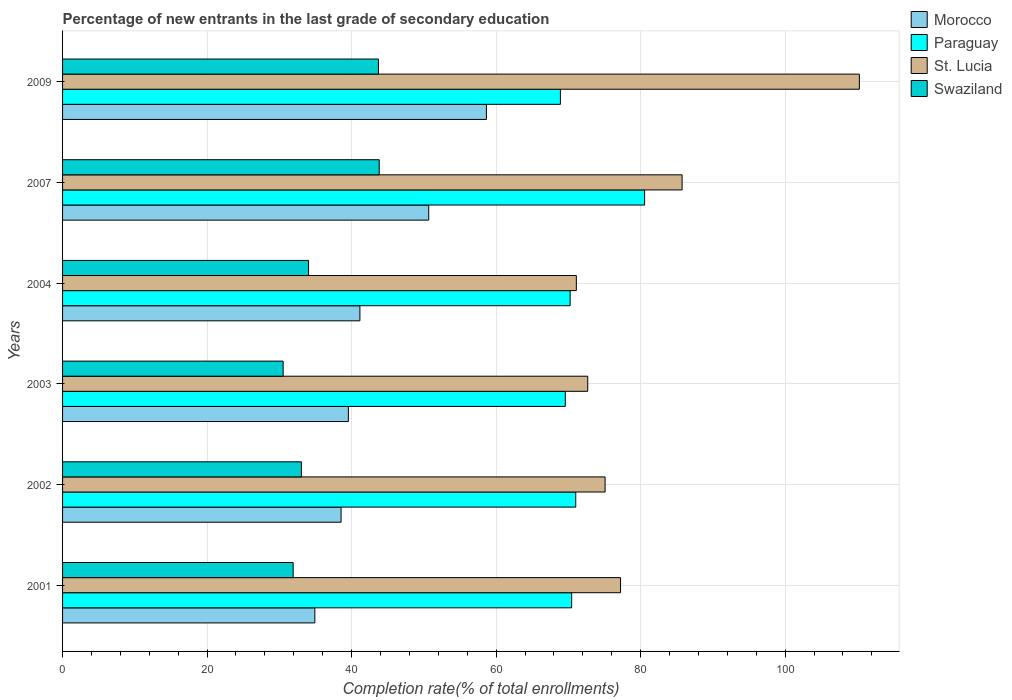How many groups of bars are there?
Offer a terse response. 6. How many bars are there on the 3rd tick from the top?
Ensure brevity in your answer.  4. In how many cases, is the number of bars for a given year not equal to the number of legend labels?
Your answer should be very brief. 0. What is the percentage of new entrants in Morocco in 2001?
Your answer should be very brief. 34.92. Across all years, what is the maximum percentage of new entrants in St. Lucia?
Keep it short and to the point. 110.28. Across all years, what is the minimum percentage of new entrants in Morocco?
Your answer should be very brief. 34.92. In which year was the percentage of new entrants in Swaziland maximum?
Keep it short and to the point. 2007. What is the total percentage of new entrants in Swaziland in the graph?
Keep it short and to the point. 217.09. What is the difference between the percentage of new entrants in Morocco in 2004 and that in 2009?
Provide a succinct answer. -17.51. What is the difference between the percentage of new entrants in Swaziland in 2004 and the percentage of new entrants in St. Lucia in 2003?
Offer a terse response. -38.64. What is the average percentage of new entrants in Morocco per year?
Your response must be concise. 43.92. In the year 2001, what is the difference between the percentage of new entrants in Paraguay and percentage of new entrants in Swaziland?
Give a very brief answer. 38.54. In how many years, is the percentage of new entrants in Paraguay greater than 72 %?
Your answer should be very brief. 1. What is the ratio of the percentage of new entrants in Morocco in 2001 to that in 2003?
Make the answer very short. 0.88. Is the percentage of new entrants in Swaziland in 2002 less than that in 2009?
Offer a terse response. Yes. What is the difference between the highest and the second highest percentage of new entrants in Morocco?
Ensure brevity in your answer.  7.99. What is the difference between the highest and the lowest percentage of new entrants in Paraguay?
Give a very brief answer. 11.65. In how many years, is the percentage of new entrants in St. Lucia greater than the average percentage of new entrants in St. Lucia taken over all years?
Ensure brevity in your answer.  2. What does the 2nd bar from the top in 2001 represents?
Your response must be concise. St. Lucia. What does the 1st bar from the bottom in 2003 represents?
Provide a short and direct response. Morocco. How many bars are there?
Your response must be concise. 24. Are all the bars in the graph horizontal?
Your response must be concise. Yes. Are the values on the major ticks of X-axis written in scientific E-notation?
Your answer should be compact. No. What is the title of the graph?
Keep it short and to the point. Percentage of new entrants in the last grade of secondary education. What is the label or title of the X-axis?
Keep it short and to the point. Completion rate(% of total enrollments). What is the label or title of the Y-axis?
Make the answer very short. Years. What is the Completion rate(% of total enrollments) of Morocco in 2001?
Give a very brief answer. 34.92. What is the Completion rate(% of total enrollments) of Paraguay in 2001?
Offer a terse response. 70.46. What is the Completion rate(% of total enrollments) of St. Lucia in 2001?
Ensure brevity in your answer.  77.23. What is the Completion rate(% of total enrollments) of Swaziland in 2001?
Your answer should be compact. 31.91. What is the Completion rate(% of total enrollments) of Morocco in 2002?
Make the answer very short. 38.55. What is the Completion rate(% of total enrollments) in Paraguay in 2002?
Ensure brevity in your answer.  71.03. What is the Completion rate(% of total enrollments) of St. Lucia in 2002?
Your answer should be very brief. 75.09. What is the Completion rate(% of total enrollments) of Swaziland in 2002?
Your answer should be compact. 33.06. What is the Completion rate(% of total enrollments) in Morocco in 2003?
Offer a terse response. 39.56. What is the Completion rate(% of total enrollments) in Paraguay in 2003?
Give a very brief answer. 69.58. What is the Completion rate(% of total enrollments) of St. Lucia in 2003?
Provide a succinct answer. 72.68. What is the Completion rate(% of total enrollments) in Swaziland in 2003?
Ensure brevity in your answer.  30.53. What is the Completion rate(% of total enrollments) in Morocco in 2004?
Offer a very short reply. 41.15. What is the Completion rate(% of total enrollments) in Paraguay in 2004?
Offer a terse response. 70.25. What is the Completion rate(% of total enrollments) in St. Lucia in 2004?
Your answer should be compact. 71.11. What is the Completion rate(% of total enrollments) in Swaziland in 2004?
Provide a short and direct response. 34.04. What is the Completion rate(% of total enrollments) in Morocco in 2007?
Provide a succinct answer. 50.67. What is the Completion rate(% of total enrollments) of Paraguay in 2007?
Offer a very short reply. 80.55. What is the Completion rate(% of total enrollments) of St. Lucia in 2007?
Your answer should be very brief. 85.74. What is the Completion rate(% of total enrollments) in Swaziland in 2007?
Your answer should be very brief. 43.83. What is the Completion rate(% of total enrollments) in Morocco in 2009?
Offer a very short reply. 58.66. What is the Completion rate(% of total enrollments) of Paraguay in 2009?
Ensure brevity in your answer.  68.9. What is the Completion rate(% of total enrollments) in St. Lucia in 2009?
Keep it short and to the point. 110.28. What is the Completion rate(% of total enrollments) in Swaziland in 2009?
Your response must be concise. 43.72. Across all years, what is the maximum Completion rate(% of total enrollments) in Morocco?
Offer a terse response. 58.66. Across all years, what is the maximum Completion rate(% of total enrollments) in Paraguay?
Your answer should be compact. 80.55. Across all years, what is the maximum Completion rate(% of total enrollments) in St. Lucia?
Make the answer very short. 110.28. Across all years, what is the maximum Completion rate(% of total enrollments) of Swaziland?
Provide a succinct answer. 43.83. Across all years, what is the minimum Completion rate(% of total enrollments) of Morocco?
Offer a very short reply. 34.92. Across all years, what is the minimum Completion rate(% of total enrollments) of Paraguay?
Your response must be concise. 68.9. Across all years, what is the minimum Completion rate(% of total enrollments) of St. Lucia?
Make the answer very short. 71.11. Across all years, what is the minimum Completion rate(% of total enrollments) in Swaziland?
Offer a very short reply. 30.53. What is the total Completion rate(% of total enrollments) of Morocco in the graph?
Your response must be concise. 263.51. What is the total Completion rate(% of total enrollments) in Paraguay in the graph?
Make the answer very short. 430.76. What is the total Completion rate(% of total enrollments) in St. Lucia in the graph?
Keep it short and to the point. 492.12. What is the total Completion rate(% of total enrollments) in Swaziland in the graph?
Your response must be concise. 217.09. What is the difference between the Completion rate(% of total enrollments) of Morocco in 2001 and that in 2002?
Keep it short and to the point. -3.63. What is the difference between the Completion rate(% of total enrollments) of Paraguay in 2001 and that in 2002?
Provide a succinct answer. -0.57. What is the difference between the Completion rate(% of total enrollments) in St. Lucia in 2001 and that in 2002?
Provide a succinct answer. 2.14. What is the difference between the Completion rate(% of total enrollments) in Swaziland in 2001 and that in 2002?
Your answer should be very brief. -1.14. What is the difference between the Completion rate(% of total enrollments) in Morocco in 2001 and that in 2003?
Offer a very short reply. -4.64. What is the difference between the Completion rate(% of total enrollments) of Paraguay in 2001 and that in 2003?
Provide a succinct answer. 0.88. What is the difference between the Completion rate(% of total enrollments) in St. Lucia in 2001 and that in 2003?
Ensure brevity in your answer.  4.54. What is the difference between the Completion rate(% of total enrollments) in Swaziland in 2001 and that in 2003?
Provide a short and direct response. 1.39. What is the difference between the Completion rate(% of total enrollments) of Morocco in 2001 and that in 2004?
Provide a short and direct response. -6.23. What is the difference between the Completion rate(% of total enrollments) of Paraguay in 2001 and that in 2004?
Offer a very short reply. 0.21. What is the difference between the Completion rate(% of total enrollments) of St. Lucia in 2001 and that in 2004?
Provide a short and direct response. 6.12. What is the difference between the Completion rate(% of total enrollments) of Swaziland in 2001 and that in 2004?
Give a very brief answer. -2.13. What is the difference between the Completion rate(% of total enrollments) in Morocco in 2001 and that in 2007?
Keep it short and to the point. -15.76. What is the difference between the Completion rate(% of total enrollments) of Paraguay in 2001 and that in 2007?
Ensure brevity in your answer.  -10.1. What is the difference between the Completion rate(% of total enrollments) of St. Lucia in 2001 and that in 2007?
Give a very brief answer. -8.52. What is the difference between the Completion rate(% of total enrollments) of Swaziland in 2001 and that in 2007?
Your response must be concise. -11.91. What is the difference between the Completion rate(% of total enrollments) of Morocco in 2001 and that in 2009?
Your response must be concise. -23.74. What is the difference between the Completion rate(% of total enrollments) of Paraguay in 2001 and that in 2009?
Ensure brevity in your answer.  1.56. What is the difference between the Completion rate(% of total enrollments) in St. Lucia in 2001 and that in 2009?
Offer a terse response. -33.05. What is the difference between the Completion rate(% of total enrollments) in Swaziland in 2001 and that in 2009?
Give a very brief answer. -11.8. What is the difference between the Completion rate(% of total enrollments) of Morocco in 2002 and that in 2003?
Make the answer very short. -1.01. What is the difference between the Completion rate(% of total enrollments) in Paraguay in 2002 and that in 2003?
Give a very brief answer. 1.45. What is the difference between the Completion rate(% of total enrollments) in St. Lucia in 2002 and that in 2003?
Keep it short and to the point. 2.4. What is the difference between the Completion rate(% of total enrollments) of Swaziland in 2002 and that in 2003?
Offer a very short reply. 2.53. What is the difference between the Completion rate(% of total enrollments) in Morocco in 2002 and that in 2004?
Keep it short and to the point. -2.61. What is the difference between the Completion rate(% of total enrollments) of Paraguay in 2002 and that in 2004?
Keep it short and to the point. 0.78. What is the difference between the Completion rate(% of total enrollments) of St. Lucia in 2002 and that in 2004?
Offer a very short reply. 3.98. What is the difference between the Completion rate(% of total enrollments) of Swaziland in 2002 and that in 2004?
Offer a very short reply. -0.99. What is the difference between the Completion rate(% of total enrollments) of Morocco in 2002 and that in 2007?
Make the answer very short. -12.13. What is the difference between the Completion rate(% of total enrollments) in Paraguay in 2002 and that in 2007?
Provide a succinct answer. -9.53. What is the difference between the Completion rate(% of total enrollments) in St. Lucia in 2002 and that in 2007?
Provide a short and direct response. -10.66. What is the difference between the Completion rate(% of total enrollments) of Swaziland in 2002 and that in 2007?
Keep it short and to the point. -10.77. What is the difference between the Completion rate(% of total enrollments) of Morocco in 2002 and that in 2009?
Provide a succinct answer. -20.12. What is the difference between the Completion rate(% of total enrollments) of Paraguay in 2002 and that in 2009?
Your answer should be very brief. 2.13. What is the difference between the Completion rate(% of total enrollments) in St. Lucia in 2002 and that in 2009?
Provide a succinct answer. -35.19. What is the difference between the Completion rate(% of total enrollments) in Swaziland in 2002 and that in 2009?
Provide a succinct answer. -10.66. What is the difference between the Completion rate(% of total enrollments) in Morocco in 2003 and that in 2004?
Offer a terse response. -1.6. What is the difference between the Completion rate(% of total enrollments) in Paraguay in 2003 and that in 2004?
Your answer should be compact. -0.67. What is the difference between the Completion rate(% of total enrollments) of St. Lucia in 2003 and that in 2004?
Make the answer very short. 1.58. What is the difference between the Completion rate(% of total enrollments) of Swaziland in 2003 and that in 2004?
Keep it short and to the point. -3.52. What is the difference between the Completion rate(% of total enrollments) in Morocco in 2003 and that in 2007?
Keep it short and to the point. -11.12. What is the difference between the Completion rate(% of total enrollments) of Paraguay in 2003 and that in 2007?
Your answer should be very brief. -10.97. What is the difference between the Completion rate(% of total enrollments) of St. Lucia in 2003 and that in 2007?
Give a very brief answer. -13.06. What is the difference between the Completion rate(% of total enrollments) of Swaziland in 2003 and that in 2007?
Provide a short and direct response. -13.3. What is the difference between the Completion rate(% of total enrollments) of Morocco in 2003 and that in 2009?
Offer a very short reply. -19.11. What is the difference between the Completion rate(% of total enrollments) of Paraguay in 2003 and that in 2009?
Offer a terse response. 0.68. What is the difference between the Completion rate(% of total enrollments) in St. Lucia in 2003 and that in 2009?
Offer a terse response. -37.59. What is the difference between the Completion rate(% of total enrollments) in Swaziland in 2003 and that in 2009?
Ensure brevity in your answer.  -13.19. What is the difference between the Completion rate(% of total enrollments) of Morocco in 2004 and that in 2007?
Provide a succinct answer. -9.52. What is the difference between the Completion rate(% of total enrollments) of Paraguay in 2004 and that in 2007?
Make the answer very short. -10.3. What is the difference between the Completion rate(% of total enrollments) of St. Lucia in 2004 and that in 2007?
Make the answer very short. -14.64. What is the difference between the Completion rate(% of total enrollments) in Swaziland in 2004 and that in 2007?
Your response must be concise. -9.78. What is the difference between the Completion rate(% of total enrollments) in Morocco in 2004 and that in 2009?
Your answer should be compact. -17.51. What is the difference between the Completion rate(% of total enrollments) in Paraguay in 2004 and that in 2009?
Provide a short and direct response. 1.35. What is the difference between the Completion rate(% of total enrollments) of St. Lucia in 2004 and that in 2009?
Give a very brief answer. -39.17. What is the difference between the Completion rate(% of total enrollments) of Swaziland in 2004 and that in 2009?
Ensure brevity in your answer.  -9.67. What is the difference between the Completion rate(% of total enrollments) in Morocco in 2007 and that in 2009?
Make the answer very short. -7.99. What is the difference between the Completion rate(% of total enrollments) in Paraguay in 2007 and that in 2009?
Offer a terse response. 11.65. What is the difference between the Completion rate(% of total enrollments) in St. Lucia in 2007 and that in 2009?
Your response must be concise. -24.53. What is the difference between the Completion rate(% of total enrollments) of Swaziland in 2007 and that in 2009?
Ensure brevity in your answer.  0.11. What is the difference between the Completion rate(% of total enrollments) in Morocco in 2001 and the Completion rate(% of total enrollments) in Paraguay in 2002?
Make the answer very short. -36.11. What is the difference between the Completion rate(% of total enrollments) of Morocco in 2001 and the Completion rate(% of total enrollments) of St. Lucia in 2002?
Keep it short and to the point. -40.17. What is the difference between the Completion rate(% of total enrollments) in Morocco in 2001 and the Completion rate(% of total enrollments) in Swaziland in 2002?
Give a very brief answer. 1.86. What is the difference between the Completion rate(% of total enrollments) of Paraguay in 2001 and the Completion rate(% of total enrollments) of St. Lucia in 2002?
Make the answer very short. -4.63. What is the difference between the Completion rate(% of total enrollments) in Paraguay in 2001 and the Completion rate(% of total enrollments) in Swaziland in 2002?
Your response must be concise. 37.4. What is the difference between the Completion rate(% of total enrollments) in St. Lucia in 2001 and the Completion rate(% of total enrollments) in Swaziland in 2002?
Keep it short and to the point. 44.17. What is the difference between the Completion rate(% of total enrollments) of Morocco in 2001 and the Completion rate(% of total enrollments) of Paraguay in 2003?
Make the answer very short. -34.66. What is the difference between the Completion rate(% of total enrollments) of Morocco in 2001 and the Completion rate(% of total enrollments) of St. Lucia in 2003?
Offer a terse response. -37.76. What is the difference between the Completion rate(% of total enrollments) in Morocco in 2001 and the Completion rate(% of total enrollments) in Swaziland in 2003?
Your response must be concise. 4.39. What is the difference between the Completion rate(% of total enrollments) in Paraguay in 2001 and the Completion rate(% of total enrollments) in St. Lucia in 2003?
Provide a short and direct response. -2.23. What is the difference between the Completion rate(% of total enrollments) of Paraguay in 2001 and the Completion rate(% of total enrollments) of Swaziland in 2003?
Keep it short and to the point. 39.93. What is the difference between the Completion rate(% of total enrollments) in St. Lucia in 2001 and the Completion rate(% of total enrollments) in Swaziland in 2003?
Offer a terse response. 46.7. What is the difference between the Completion rate(% of total enrollments) of Morocco in 2001 and the Completion rate(% of total enrollments) of Paraguay in 2004?
Provide a short and direct response. -35.33. What is the difference between the Completion rate(% of total enrollments) of Morocco in 2001 and the Completion rate(% of total enrollments) of St. Lucia in 2004?
Offer a very short reply. -36.19. What is the difference between the Completion rate(% of total enrollments) in Morocco in 2001 and the Completion rate(% of total enrollments) in Swaziland in 2004?
Your answer should be very brief. 0.88. What is the difference between the Completion rate(% of total enrollments) in Paraguay in 2001 and the Completion rate(% of total enrollments) in St. Lucia in 2004?
Your answer should be very brief. -0.65. What is the difference between the Completion rate(% of total enrollments) of Paraguay in 2001 and the Completion rate(% of total enrollments) of Swaziland in 2004?
Provide a short and direct response. 36.41. What is the difference between the Completion rate(% of total enrollments) of St. Lucia in 2001 and the Completion rate(% of total enrollments) of Swaziland in 2004?
Offer a very short reply. 43.18. What is the difference between the Completion rate(% of total enrollments) in Morocco in 2001 and the Completion rate(% of total enrollments) in Paraguay in 2007?
Keep it short and to the point. -45.63. What is the difference between the Completion rate(% of total enrollments) in Morocco in 2001 and the Completion rate(% of total enrollments) in St. Lucia in 2007?
Provide a succinct answer. -50.82. What is the difference between the Completion rate(% of total enrollments) of Morocco in 2001 and the Completion rate(% of total enrollments) of Swaziland in 2007?
Your answer should be very brief. -8.91. What is the difference between the Completion rate(% of total enrollments) of Paraguay in 2001 and the Completion rate(% of total enrollments) of St. Lucia in 2007?
Provide a succinct answer. -15.29. What is the difference between the Completion rate(% of total enrollments) in Paraguay in 2001 and the Completion rate(% of total enrollments) in Swaziland in 2007?
Offer a terse response. 26.63. What is the difference between the Completion rate(% of total enrollments) of St. Lucia in 2001 and the Completion rate(% of total enrollments) of Swaziland in 2007?
Ensure brevity in your answer.  33.4. What is the difference between the Completion rate(% of total enrollments) in Morocco in 2001 and the Completion rate(% of total enrollments) in Paraguay in 2009?
Your response must be concise. -33.98. What is the difference between the Completion rate(% of total enrollments) of Morocco in 2001 and the Completion rate(% of total enrollments) of St. Lucia in 2009?
Your answer should be compact. -75.36. What is the difference between the Completion rate(% of total enrollments) of Morocco in 2001 and the Completion rate(% of total enrollments) of Swaziland in 2009?
Give a very brief answer. -8.8. What is the difference between the Completion rate(% of total enrollments) in Paraguay in 2001 and the Completion rate(% of total enrollments) in St. Lucia in 2009?
Give a very brief answer. -39.82. What is the difference between the Completion rate(% of total enrollments) in Paraguay in 2001 and the Completion rate(% of total enrollments) in Swaziland in 2009?
Provide a succinct answer. 26.74. What is the difference between the Completion rate(% of total enrollments) of St. Lucia in 2001 and the Completion rate(% of total enrollments) of Swaziland in 2009?
Your answer should be very brief. 33.51. What is the difference between the Completion rate(% of total enrollments) of Morocco in 2002 and the Completion rate(% of total enrollments) of Paraguay in 2003?
Your answer should be very brief. -31.03. What is the difference between the Completion rate(% of total enrollments) of Morocco in 2002 and the Completion rate(% of total enrollments) of St. Lucia in 2003?
Make the answer very short. -34.14. What is the difference between the Completion rate(% of total enrollments) in Morocco in 2002 and the Completion rate(% of total enrollments) in Swaziland in 2003?
Offer a very short reply. 8.02. What is the difference between the Completion rate(% of total enrollments) in Paraguay in 2002 and the Completion rate(% of total enrollments) in St. Lucia in 2003?
Your response must be concise. -1.66. What is the difference between the Completion rate(% of total enrollments) of Paraguay in 2002 and the Completion rate(% of total enrollments) of Swaziland in 2003?
Your answer should be compact. 40.5. What is the difference between the Completion rate(% of total enrollments) in St. Lucia in 2002 and the Completion rate(% of total enrollments) in Swaziland in 2003?
Offer a terse response. 44.56. What is the difference between the Completion rate(% of total enrollments) of Morocco in 2002 and the Completion rate(% of total enrollments) of Paraguay in 2004?
Offer a terse response. -31.7. What is the difference between the Completion rate(% of total enrollments) in Morocco in 2002 and the Completion rate(% of total enrollments) in St. Lucia in 2004?
Offer a terse response. -32.56. What is the difference between the Completion rate(% of total enrollments) of Morocco in 2002 and the Completion rate(% of total enrollments) of Swaziland in 2004?
Ensure brevity in your answer.  4.5. What is the difference between the Completion rate(% of total enrollments) in Paraguay in 2002 and the Completion rate(% of total enrollments) in St. Lucia in 2004?
Provide a succinct answer. -0.08. What is the difference between the Completion rate(% of total enrollments) of Paraguay in 2002 and the Completion rate(% of total enrollments) of Swaziland in 2004?
Keep it short and to the point. 36.98. What is the difference between the Completion rate(% of total enrollments) of St. Lucia in 2002 and the Completion rate(% of total enrollments) of Swaziland in 2004?
Your answer should be very brief. 41.04. What is the difference between the Completion rate(% of total enrollments) of Morocco in 2002 and the Completion rate(% of total enrollments) of Paraguay in 2007?
Offer a very short reply. -42.01. What is the difference between the Completion rate(% of total enrollments) in Morocco in 2002 and the Completion rate(% of total enrollments) in St. Lucia in 2007?
Provide a succinct answer. -47.2. What is the difference between the Completion rate(% of total enrollments) of Morocco in 2002 and the Completion rate(% of total enrollments) of Swaziland in 2007?
Your answer should be compact. -5.28. What is the difference between the Completion rate(% of total enrollments) in Paraguay in 2002 and the Completion rate(% of total enrollments) in St. Lucia in 2007?
Keep it short and to the point. -14.72. What is the difference between the Completion rate(% of total enrollments) in Paraguay in 2002 and the Completion rate(% of total enrollments) in Swaziland in 2007?
Make the answer very short. 27.2. What is the difference between the Completion rate(% of total enrollments) of St. Lucia in 2002 and the Completion rate(% of total enrollments) of Swaziland in 2007?
Offer a very short reply. 31.26. What is the difference between the Completion rate(% of total enrollments) of Morocco in 2002 and the Completion rate(% of total enrollments) of Paraguay in 2009?
Keep it short and to the point. -30.35. What is the difference between the Completion rate(% of total enrollments) of Morocco in 2002 and the Completion rate(% of total enrollments) of St. Lucia in 2009?
Your answer should be compact. -71.73. What is the difference between the Completion rate(% of total enrollments) of Morocco in 2002 and the Completion rate(% of total enrollments) of Swaziland in 2009?
Your response must be concise. -5.17. What is the difference between the Completion rate(% of total enrollments) in Paraguay in 2002 and the Completion rate(% of total enrollments) in St. Lucia in 2009?
Your answer should be compact. -39.25. What is the difference between the Completion rate(% of total enrollments) of Paraguay in 2002 and the Completion rate(% of total enrollments) of Swaziland in 2009?
Give a very brief answer. 27.31. What is the difference between the Completion rate(% of total enrollments) in St. Lucia in 2002 and the Completion rate(% of total enrollments) in Swaziland in 2009?
Your answer should be compact. 31.37. What is the difference between the Completion rate(% of total enrollments) in Morocco in 2003 and the Completion rate(% of total enrollments) in Paraguay in 2004?
Make the answer very short. -30.69. What is the difference between the Completion rate(% of total enrollments) in Morocco in 2003 and the Completion rate(% of total enrollments) in St. Lucia in 2004?
Offer a terse response. -31.55. What is the difference between the Completion rate(% of total enrollments) of Morocco in 2003 and the Completion rate(% of total enrollments) of Swaziland in 2004?
Ensure brevity in your answer.  5.51. What is the difference between the Completion rate(% of total enrollments) of Paraguay in 2003 and the Completion rate(% of total enrollments) of St. Lucia in 2004?
Give a very brief answer. -1.53. What is the difference between the Completion rate(% of total enrollments) in Paraguay in 2003 and the Completion rate(% of total enrollments) in Swaziland in 2004?
Provide a short and direct response. 35.54. What is the difference between the Completion rate(% of total enrollments) in St. Lucia in 2003 and the Completion rate(% of total enrollments) in Swaziland in 2004?
Your answer should be very brief. 38.64. What is the difference between the Completion rate(% of total enrollments) in Morocco in 2003 and the Completion rate(% of total enrollments) in Paraguay in 2007?
Give a very brief answer. -41. What is the difference between the Completion rate(% of total enrollments) in Morocco in 2003 and the Completion rate(% of total enrollments) in St. Lucia in 2007?
Your response must be concise. -46.19. What is the difference between the Completion rate(% of total enrollments) in Morocco in 2003 and the Completion rate(% of total enrollments) in Swaziland in 2007?
Provide a succinct answer. -4.27. What is the difference between the Completion rate(% of total enrollments) of Paraguay in 2003 and the Completion rate(% of total enrollments) of St. Lucia in 2007?
Make the answer very short. -16.16. What is the difference between the Completion rate(% of total enrollments) in Paraguay in 2003 and the Completion rate(% of total enrollments) in Swaziland in 2007?
Offer a terse response. 25.75. What is the difference between the Completion rate(% of total enrollments) in St. Lucia in 2003 and the Completion rate(% of total enrollments) in Swaziland in 2007?
Offer a very short reply. 28.86. What is the difference between the Completion rate(% of total enrollments) in Morocco in 2003 and the Completion rate(% of total enrollments) in Paraguay in 2009?
Ensure brevity in your answer.  -29.34. What is the difference between the Completion rate(% of total enrollments) in Morocco in 2003 and the Completion rate(% of total enrollments) in St. Lucia in 2009?
Offer a terse response. -70.72. What is the difference between the Completion rate(% of total enrollments) in Morocco in 2003 and the Completion rate(% of total enrollments) in Swaziland in 2009?
Provide a short and direct response. -4.16. What is the difference between the Completion rate(% of total enrollments) in Paraguay in 2003 and the Completion rate(% of total enrollments) in St. Lucia in 2009?
Offer a very short reply. -40.7. What is the difference between the Completion rate(% of total enrollments) in Paraguay in 2003 and the Completion rate(% of total enrollments) in Swaziland in 2009?
Your answer should be compact. 25.86. What is the difference between the Completion rate(% of total enrollments) of St. Lucia in 2003 and the Completion rate(% of total enrollments) of Swaziland in 2009?
Provide a succinct answer. 28.97. What is the difference between the Completion rate(% of total enrollments) of Morocco in 2004 and the Completion rate(% of total enrollments) of Paraguay in 2007?
Provide a succinct answer. -39.4. What is the difference between the Completion rate(% of total enrollments) of Morocco in 2004 and the Completion rate(% of total enrollments) of St. Lucia in 2007?
Your answer should be very brief. -44.59. What is the difference between the Completion rate(% of total enrollments) in Morocco in 2004 and the Completion rate(% of total enrollments) in Swaziland in 2007?
Offer a terse response. -2.68. What is the difference between the Completion rate(% of total enrollments) of Paraguay in 2004 and the Completion rate(% of total enrollments) of St. Lucia in 2007?
Offer a very short reply. -15.5. What is the difference between the Completion rate(% of total enrollments) of Paraguay in 2004 and the Completion rate(% of total enrollments) of Swaziland in 2007?
Offer a terse response. 26.42. What is the difference between the Completion rate(% of total enrollments) in St. Lucia in 2004 and the Completion rate(% of total enrollments) in Swaziland in 2007?
Ensure brevity in your answer.  27.28. What is the difference between the Completion rate(% of total enrollments) in Morocco in 2004 and the Completion rate(% of total enrollments) in Paraguay in 2009?
Offer a very short reply. -27.75. What is the difference between the Completion rate(% of total enrollments) of Morocco in 2004 and the Completion rate(% of total enrollments) of St. Lucia in 2009?
Your answer should be compact. -69.12. What is the difference between the Completion rate(% of total enrollments) in Morocco in 2004 and the Completion rate(% of total enrollments) in Swaziland in 2009?
Ensure brevity in your answer.  -2.57. What is the difference between the Completion rate(% of total enrollments) in Paraguay in 2004 and the Completion rate(% of total enrollments) in St. Lucia in 2009?
Your answer should be very brief. -40.03. What is the difference between the Completion rate(% of total enrollments) in Paraguay in 2004 and the Completion rate(% of total enrollments) in Swaziland in 2009?
Your response must be concise. 26.53. What is the difference between the Completion rate(% of total enrollments) in St. Lucia in 2004 and the Completion rate(% of total enrollments) in Swaziland in 2009?
Your answer should be very brief. 27.39. What is the difference between the Completion rate(% of total enrollments) of Morocco in 2007 and the Completion rate(% of total enrollments) of Paraguay in 2009?
Provide a succinct answer. -18.23. What is the difference between the Completion rate(% of total enrollments) in Morocco in 2007 and the Completion rate(% of total enrollments) in St. Lucia in 2009?
Offer a terse response. -59.6. What is the difference between the Completion rate(% of total enrollments) of Morocco in 2007 and the Completion rate(% of total enrollments) of Swaziland in 2009?
Offer a very short reply. 6.96. What is the difference between the Completion rate(% of total enrollments) of Paraguay in 2007 and the Completion rate(% of total enrollments) of St. Lucia in 2009?
Make the answer very short. -29.72. What is the difference between the Completion rate(% of total enrollments) in Paraguay in 2007 and the Completion rate(% of total enrollments) in Swaziland in 2009?
Make the answer very short. 36.83. What is the difference between the Completion rate(% of total enrollments) of St. Lucia in 2007 and the Completion rate(% of total enrollments) of Swaziland in 2009?
Make the answer very short. 42.03. What is the average Completion rate(% of total enrollments) in Morocco per year?
Your answer should be compact. 43.92. What is the average Completion rate(% of total enrollments) of Paraguay per year?
Provide a succinct answer. 71.79. What is the average Completion rate(% of total enrollments) in St. Lucia per year?
Keep it short and to the point. 82.02. What is the average Completion rate(% of total enrollments) of Swaziland per year?
Offer a very short reply. 36.18. In the year 2001, what is the difference between the Completion rate(% of total enrollments) of Morocco and Completion rate(% of total enrollments) of Paraguay?
Give a very brief answer. -35.54. In the year 2001, what is the difference between the Completion rate(% of total enrollments) in Morocco and Completion rate(% of total enrollments) in St. Lucia?
Provide a succinct answer. -42.31. In the year 2001, what is the difference between the Completion rate(% of total enrollments) of Morocco and Completion rate(% of total enrollments) of Swaziland?
Offer a terse response. 3. In the year 2001, what is the difference between the Completion rate(% of total enrollments) of Paraguay and Completion rate(% of total enrollments) of St. Lucia?
Your answer should be compact. -6.77. In the year 2001, what is the difference between the Completion rate(% of total enrollments) of Paraguay and Completion rate(% of total enrollments) of Swaziland?
Keep it short and to the point. 38.54. In the year 2001, what is the difference between the Completion rate(% of total enrollments) of St. Lucia and Completion rate(% of total enrollments) of Swaziland?
Ensure brevity in your answer.  45.31. In the year 2002, what is the difference between the Completion rate(% of total enrollments) of Morocco and Completion rate(% of total enrollments) of Paraguay?
Your answer should be very brief. -32.48. In the year 2002, what is the difference between the Completion rate(% of total enrollments) in Morocco and Completion rate(% of total enrollments) in St. Lucia?
Make the answer very short. -36.54. In the year 2002, what is the difference between the Completion rate(% of total enrollments) in Morocco and Completion rate(% of total enrollments) in Swaziland?
Provide a short and direct response. 5.49. In the year 2002, what is the difference between the Completion rate(% of total enrollments) in Paraguay and Completion rate(% of total enrollments) in St. Lucia?
Make the answer very short. -4.06. In the year 2002, what is the difference between the Completion rate(% of total enrollments) in Paraguay and Completion rate(% of total enrollments) in Swaziland?
Your response must be concise. 37.97. In the year 2002, what is the difference between the Completion rate(% of total enrollments) of St. Lucia and Completion rate(% of total enrollments) of Swaziland?
Your answer should be compact. 42.03. In the year 2003, what is the difference between the Completion rate(% of total enrollments) of Morocco and Completion rate(% of total enrollments) of Paraguay?
Provide a succinct answer. -30.02. In the year 2003, what is the difference between the Completion rate(% of total enrollments) in Morocco and Completion rate(% of total enrollments) in St. Lucia?
Your answer should be very brief. -33.13. In the year 2003, what is the difference between the Completion rate(% of total enrollments) of Morocco and Completion rate(% of total enrollments) of Swaziland?
Ensure brevity in your answer.  9.03. In the year 2003, what is the difference between the Completion rate(% of total enrollments) in Paraguay and Completion rate(% of total enrollments) in St. Lucia?
Keep it short and to the point. -3.1. In the year 2003, what is the difference between the Completion rate(% of total enrollments) in Paraguay and Completion rate(% of total enrollments) in Swaziland?
Keep it short and to the point. 39.05. In the year 2003, what is the difference between the Completion rate(% of total enrollments) in St. Lucia and Completion rate(% of total enrollments) in Swaziland?
Your answer should be compact. 42.16. In the year 2004, what is the difference between the Completion rate(% of total enrollments) of Morocco and Completion rate(% of total enrollments) of Paraguay?
Provide a succinct answer. -29.1. In the year 2004, what is the difference between the Completion rate(% of total enrollments) of Morocco and Completion rate(% of total enrollments) of St. Lucia?
Provide a short and direct response. -29.96. In the year 2004, what is the difference between the Completion rate(% of total enrollments) of Morocco and Completion rate(% of total enrollments) of Swaziland?
Make the answer very short. 7.11. In the year 2004, what is the difference between the Completion rate(% of total enrollments) of Paraguay and Completion rate(% of total enrollments) of St. Lucia?
Give a very brief answer. -0.86. In the year 2004, what is the difference between the Completion rate(% of total enrollments) of Paraguay and Completion rate(% of total enrollments) of Swaziland?
Offer a terse response. 36.2. In the year 2004, what is the difference between the Completion rate(% of total enrollments) of St. Lucia and Completion rate(% of total enrollments) of Swaziland?
Provide a succinct answer. 37.06. In the year 2007, what is the difference between the Completion rate(% of total enrollments) of Morocco and Completion rate(% of total enrollments) of Paraguay?
Ensure brevity in your answer.  -29.88. In the year 2007, what is the difference between the Completion rate(% of total enrollments) in Morocco and Completion rate(% of total enrollments) in St. Lucia?
Make the answer very short. -35.07. In the year 2007, what is the difference between the Completion rate(% of total enrollments) of Morocco and Completion rate(% of total enrollments) of Swaziland?
Give a very brief answer. 6.85. In the year 2007, what is the difference between the Completion rate(% of total enrollments) of Paraguay and Completion rate(% of total enrollments) of St. Lucia?
Give a very brief answer. -5.19. In the year 2007, what is the difference between the Completion rate(% of total enrollments) in Paraguay and Completion rate(% of total enrollments) in Swaziland?
Ensure brevity in your answer.  36.72. In the year 2007, what is the difference between the Completion rate(% of total enrollments) of St. Lucia and Completion rate(% of total enrollments) of Swaziland?
Your response must be concise. 41.92. In the year 2009, what is the difference between the Completion rate(% of total enrollments) in Morocco and Completion rate(% of total enrollments) in Paraguay?
Give a very brief answer. -10.24. In the year 2009, what is the difference between the Completion rate(% of total enrollments) in Morocco and Completion rate(% of total enrollments) in St. Lucia?
Your response must be concise. -51.61. In the year 2009, what is the difference between the Completion rate(% of total enrollments) of Morocco and Completion rate(% of total enrollments) of Swaziland?
Ensure brevity in your answer.  14.94. In the year 2009, what is the difference between the Completion rate(% of total enrollments) in Paraguay and Completion rate(% of total enrollments) in St. Lucia?
Give a very brief answer. -41.38. In the year 2009, what is the difference between the Completion rate(% of total enrollments) in Paraguay and Completion rate(% of total enrollments) in Swaziland?
Provide a short and direct response. 25.18. In the year 2009, what is the difference between the Completion rate(% of total enrollments) in St. Lucia and Completion rate(% of total enrollments) in Swaziland?
Offer a terse response. 66.56. What is the ratio of the Completion rate(% of total enrollments) of Morocco in 2001 to that in 2002?
Your answer should be very brief. 0.91. What is the ratio of the Completion rate(% of total enrollments) of Paraguay in 2001 to that in 2002?
Provide a succinct answer. 0.99. What is the ratio of the Completion rate(% of total enrollments) of St. Lucia in 2001 to that in 2002?
Keep it short and to the point. 1.03. What is the ratio of the Completion rate(% of total enrollments) in Swaziland in 2001 to that in 2002?
Offer a very short reply. 0.97. What is the ratio of the Completion rate(% of total enrollments) of Morocco in 2001 to that in 2003?
Provide a succinct answer. 0.88. What is the ratio of the Completion rate(% of total enrollments) in Paraguay in 2001 to that in 2003?
Keep it short and to the point. 1.01. What is the ratio of the Completion rate(% of total enrollments) in St. Lucia in 2001 to that in 2003?
Ensure brevity in your answer.  1.06. What is the ratio of the Completion rate(% of total enrollments) in Swaziland in 2001 to that in 2003?
Your answer should be very brief. 1.05. What is the ratio of the Completion rate(% of total enrollments) in Morocco in 2001 to that in 2004?
Your answer should be compact. 0.85. What is the ratio of the Completion rate(% of total enrollments) of St. Lucia in 2001 to that in 2004?
Your answer should be very brief. 1.09. What is the ratio of the Completion rate(% of total enrollments) in Morocco in 2001 to that in 2007?
Ensure brevity in your answer.  0.69. What is the ratio of the Completion rate(% of total enrollments) of Paraguay in 2001 to that in 2007?
Offer a terse response. 0.87. What is the ratio of the Completion rate(% of total enrollments) in St. Lucia in 2001 to that in 2007?
Provide a short and direct response. 0.9. What is the ratio of the Completion rate(% of total enrollments) in Swaziland in 2001 to that in 2007?
Keep it short and to the point. 0.73. What is the ratio of the Completion rate(% of total enrollments) of Morocco in 2001 to that in 2009?
Give a very brief answer. 0.6. What is the ratio of the Completion rate(% of total enrollments) of Paraguay in 2001 to that in 2009?
Give a very brief answer. 1.02. What is the ratio of the Completion rate(% of total enrollments) of St. Lucia in 2001 to that in 2009?
Make the answer very short. 0.7. What is the ratio of the Completion rate(% of total enrollments) in Swaziland in 2001 to that in 2009?
Your answer should be compact. 0.73. What is the ratio of the Completion rate(% of total enrollments) of Morocco in 2002 to that in 2003?
Make the answer very short. 0.97. What is the ratio of the Completion rate(% of total enrollments) of Paraguay in 2002 to that in 2003?
Your answer should be compact. 1.02. What is the ratio of the Completion rate(% of total enrollments) in St. Lucia in 2002 to that in 2003?
Provide a short and direct response. 1.03. What is the ratio of the Completion rate(% of total enrollments) of Swaziland in 2002 to that in 2003?
Offer a very short reply. 1.08. What is the ratio of the Completion rate(% of total enrollments) in Morocco in 2002 to that in 2004?
Offer a very short reply. 0.94. What is the ratio of the Completion rate(% of total enrollments) in Paraguay in 2002 to that in 2004?
Provide a short and direct response. 1.01. What is the ratio of the Completion rate(% of total enrollments) in St. Lucia in 2002 to that in 2004?
Your answer should be very brief. 1.06. What is the ratio of the Completion rate(% of total enrollments) of Swaziland in 2002 to that in 2004?
Your answer should be compact. 0.97. What is the ratio of the Completion rate(% of total enrollments) in Morocco in 2002 to that in 2007?
Your answer should be very brief. 0.76. What is the ratio of the Completion rate(% of total enrollments) of Paraguay in 2002 to that in 2007?
Offer a very short reply. 0.88. What is the ratio of the Completion rate(% of total enrollments) of St. Lucia in 2002 to that in 2007?
Ensure brevity in your answer.  0.88. What is the ratio of the Completion rate(% of total enrollments) in Swaziland in 2002 to that in 2007?
Provide a succinct answer. 0.75. What is the ratio of the Completion rate(% of total enrollments) in Morocco in 2002 to that in 2009?
Give a very brief answer. 0.66. What is the ratio of the Completion rate(% of total enrollments) in Paraguay in 2002 to that in 2009?
Provide a short and direct response. 1.03. What is the ratio of the Completion rate(% of total enrollments) in St. Lucia in 2002 to that in 2009?
Ensure brevity in your answer.  0.68. What is the ratio of the Completion rate(% of total enrollments) in Swaziland in 2002 to that in 2009?
Keep it short and to the point. 0.76. What is the ratio of the Completion rate(% of total enrollments) in Morocco in 2003 to that in 2004?
Your answer should be compact. 0.96. What is the ratio of the Completion rate(% of total enrollments) of St. Lucia in 2003 to that in 2004?
Provide a short and direct response. 1.02. What is the ratio of the Completion rate(% of total enrollments) in Swaziland in 2003 to that in 2004?
Give a very brief answer. 0.9. What is the ratio of the Completion rate(% of total enrollments) in Morocco in 2003 to that in 2007?
Make the answer very short. 0.78. What is the ratio of the Completion rate(% of total enrollments) in Paraguay in 2003 to that in 2007?
Make the answer very short. 0.86. What is the ratio of the Completion rate(% of total enrollments) of St. Lucia in 2003 to that in 2007?
Your response must be concise. 0.85. What is the ratio of the Completion rate(% of total enrollments) in Swaziland in 2003 to that in 2007?
Your response must be concise. 0.7. What is the ratio of the Completion rate(% of total enrollments) of Morocco in 2003 to that in 2009?
Offer a very short reply. 0.67. What is the ratio of the Completion rate(% of total enrollments) in Paraguay in 2003 to that in 2009?
Ensure brevity in your answer.  1.01. What is the ratio of the Completion rate(% of total enrollments) of St. Lucia in 2003 to that in 2009?
Give a very brief answer. 0.66. What is the ratio of the Completion rate(% of total enrollments) in Swaziland in 2003 to that in 2009?
Ensure brevity in your answer.  0.7. What is the ratio of the Completion rate(% of total enrollments) of Morocco in 2004 to that in 2007?
Your answer should be very brief. 0.81. What is the ratio of the Completion rate(% of total enrollments) in Paraguay in 2004 to that in 2007?
Provide a succinct answer. 0.87. What is the ratio of the Completion rate(% of total enrollments) of St. Lucia in 2004 to that in 2007?
Give a very brief answer. 0.83. What is the ratio of the Completion rate(% of total enrollments) in Swaziland in 2004 to that in 2007?
Offer a very short reply. 0.78. What is the ratio of the Completion rate(% of total enrollments) of Morocco in 2004 to that in 2009?
Offer a terse response. 0.7. What is the ratio of the Completion rate(% of total enrollments) in Paraguay in 2004 to that in 2009?
Keep it short and to the point. 1.02. What is the ratio of the Completion rate(% of total enrollments) of St. Lucia in 2004 to that in 2009?
Ensure brevity in your answer.  0.64. What is the ratio of the Completion rate(% of total enrollments) of Swaziland in 2004 to that in 2009?
Offer a terse response. 0.78. What is the ratio of the Completion rate(% of total enrollments) in Morocco in 2007 to that in 2009?
Your answer should be compact. 0.86. What is the ratio of the Completion rate(% of total enrollments) of Paraguay in 2007 to that in 2009?
Offer a terse response. 1.17. What is the ratio of the Completion rate(% of total enrollments) of St. Lucia in 2007 to that in 2009?
Your answer should be very brief. 0.78. What is the ratio of the Completion rate(% of total enrollments) in Swaziland in 2007 to that in 2009?
Offer a terse response. 1. What is the difference between the highest and the second highest Completion rate(% of total enrollments) in Morocco?
Make the answer very short. 7.99. What is the difference between the highest and the second highest Completion rate(% of total enrollments) of Paraguay?
Offer a very short reply. 9.53. What is the difference between the highest and the second highest Completion rate(% of total enrollments) of St. Lucia?
Ensure brevity in your answer.  24.53. What is the difference between the highest and the second highest Completion rate(% of total enrollments) of Swaziland?
Provide a short and direct response. 0.11. What is the difference between the highest and the lowest Completion rate(% of total enrollments) of Morocco?
Provide a succinct answer. 23.74. What is the difference between the highest and the lowest Completion rate(% of total enrollments) in Paraguay?
Ensure brevity in your answer.  11.65. What is the difference between the highest and the lowest Completion rate(% of total enrollments) in St. Lucia?
Provide a succinct answer. 39.17. What is the difference between the highest and the lowest Completion rate(% of total enrollments) of Swaziland?
Make the answer very short. 13.3. 